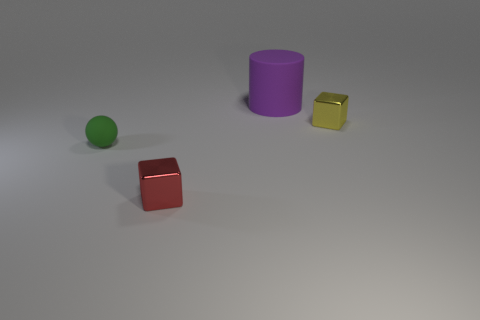Add 4 red cubes. How many objects exist? 8 Subtract all cylinders. How many objects are left? 3 Add 4 red blocks. How many red blocks are left? 5 Add 4 big things. How many big things exist? 5 Subtract 1 yellow cubes. How many objects are left? 3 Subtract all rubber cylinders. Subtract all big brown cubes. How many objects are left? 3 